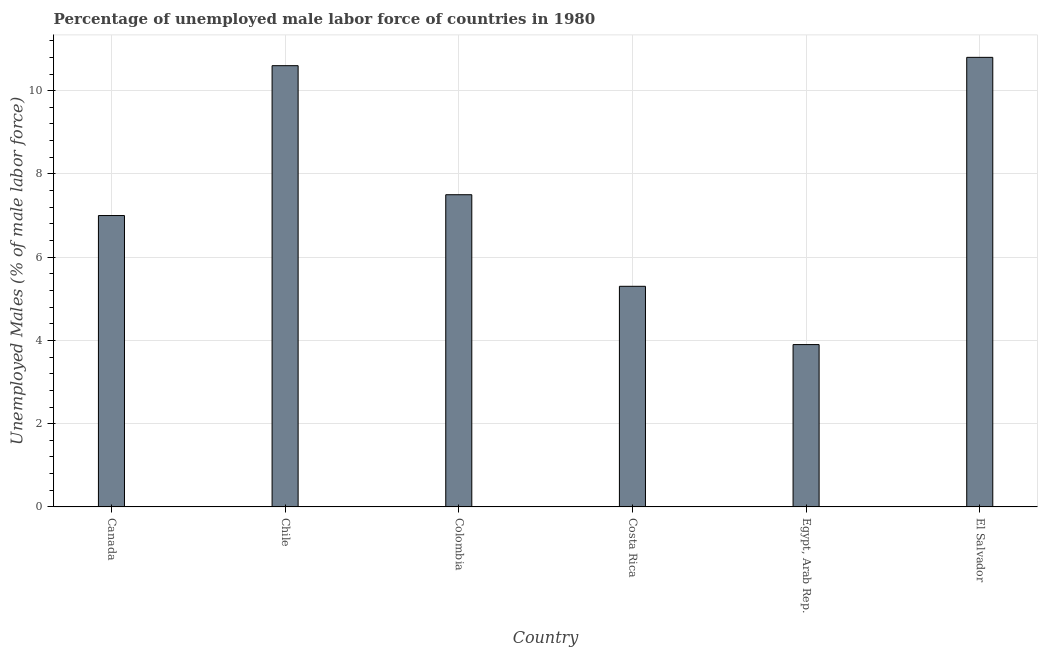Does the graph contain grids?
Your answer should be very brief. Yes. What is the title of the graph?
Your answer should be very brief. Percentage of unemployed male labor force of countries in 1980. What is the label or title of the Y-axis?
Give a very brief answer. Unemployed Males (% of male labor force). What is the total unemployed male labour force in Canada?
Keep it short and to the point. 7. Across all countries, what is the maximum total unemployed male labour force?
Offer a terse response. 10.8. Across all countries, what is the minimum total unemployed male labour force?
Ensure brevity in your answer.  3.9. In which country was the total unemployed male labour force maximum?
Provide a short and direct response. El Salvador. In which country was the total unemployed male labour force minimum?
Your answer should be compact. Egypt, Arab Rep. What is the sum of the total unemployed male labour force?
Make the answer very short. 45.1. What is the difference between the total unemployed male labour force in Chile and Colombia?
Keep it short and to the point. 3.1. What is the average total unemployed male labour force per country?
Ensure brevity in your answer.  7.52. What is the median total unemployed male labour force?
Offer a terse response. 7.25. In how many countries, is the total unemployed male labour force greater than 8 %?
Provide a succinct answer. 2. What is the ratio of the total unemployed male labour force in Chile to that in Egypt, Arab Rep.?
Make the answer very short. 2.72. What is the difference between the highest and the second highest total unemployed male labour force?
Keep it short and to the point. 0.2. What is the difference between the highest and the lowest total unemployed male labour force?
Your answer should be compact. 6.9. In how many countries, is the total unemployed male labour force greater than the average total unemployed male labour force taken over all countries?
Your answer should be compact. 2. How many bars are there?
Offer a very short reply. 6. Are all the bars in the graph horizontal?
Your answer should be very brief. No. Are the values on the major ticks of Y-axis written in scientific E-notation?
Offer a very short reply. No. What is the Unemployed Males (% of male labor force) of Chile?
Your response must be concise. 10.6. What is the Unemployed Males (% of male labor force) in Colombia?
Provide a short and direct response. 7.5. What is the Unemployed Males (% of male labor force) in Costa Rica?
Keep it short and to the point. 5.3. What is the Unemployed Males (% of male labor force) in Egypt, Arab Rep.?
Give a very brief answer. 3.9. What is the Unemployed Males (% of male labor force) of El Salvador?
Keep it short and to the point. 10.8. What is the difference between the Unemployed Males (% of male labor force) in Canada and Colombia?
Offer a very short reply. -0.5. What is the difference between the Unemployed Males (% of male labor force) in Canada and El Salvador?
Your response must be concise. -3.8. What is the difference between the Unemployed Males (% of male labor force) in Chile and Colombia?
Your answer should be very brief. 3.1. What is the difference between the Unemployed Males (% of male labor force) in Chile and Egypt, Arab Rep.?
Keep it short and to the point. 6.7. What is the difference between the Unemployed Males (% of male labor force) in Colombia and Costa Rica?
Give a very brief answer. 2.2. What is the difference between the Unemployed Males (% of male labor force) in Colombia and Egypt, Arab Rep.?
Your answer should be compact. 3.6. What is the difference between the Unemployed Males (% of male labor force) in Colombia and El Salvador?
Your answer should be very brief. -3.3. What is the difference between the Unemployed Males (% of male labor force) in Egypt, Arab Rep. and El Salvador?
Offer a very short reply. -6.9. What is the ratio of the Unemployed Males (% of male labor force) in Canada to that in Chile?
Your answer should be very brief. 0.66. What is the ratio of the Unemployed Males (% of male labor force) in Canada to that in Colombia?
Ensure brevity in your answer.  0.93. What is the ratio of the Unemployed Males (% of male labor force) in Canada to that in Costa Rica?
Provide a short and direct response. 1.32. What is the ratio of the Unemployed Males (% of male labor force) in Canada to that in Egypt, Arab Rep.?
Ensure brevity in your answer.  1.79. What is the ratio of the Unemployed Males (% of male labor force) in Canada to that in El Salvador?
Give a very brief answer. 0.65. What is the ratio of the Unemployed Males (% of male labor force) in Chile to that in Colombia?
Make the answer very short. 1.41. What is the ratio of the Unemployed Males (% of male labor force) in Chile to that in Costa Rica?
Your answer should be very brief. 2. What is the ratio of the Unemployed Males (% of male labor force) in Chile to that in Egypt, Arab Rep.?
Make the answer very short. 2.72. What is the ratio of the Unemployed Males (% of male labor force) in Chile to that in El Salvador?
Offer a very short reply. 0.98. What is the ratio of the Unemployed Males (% of male labor force) in Colombia to that in Costa Rica?
Give a very brief answer. 1.42. What is the ratio of the Unemployed Males (% of male labor force) in Colombia to that in Egypt, Arab Rep.?
Make the answer very short. 1.92. What is the ratio of the Unemployed Males (% of male labor force) in Colombia to that in El Salvador?
Provide a succinct answer. 0.69. What is the ratio of the Unemployed Males (% of male labor force) in Costa Rica to that in Egypt, Arab Rep.?
Your answer should be very brief. 1.36. What is the ratio of the Unemployed Males (% of male labor force) in Costa Rica to that in El Salvador?
Provide a short and direct response. 0.49. What is the ratio of the Unemployed Males (% of male labor force) in Egypt, Arab Rep. to that in El Salvador?
Your response must be concise. 0.36. 